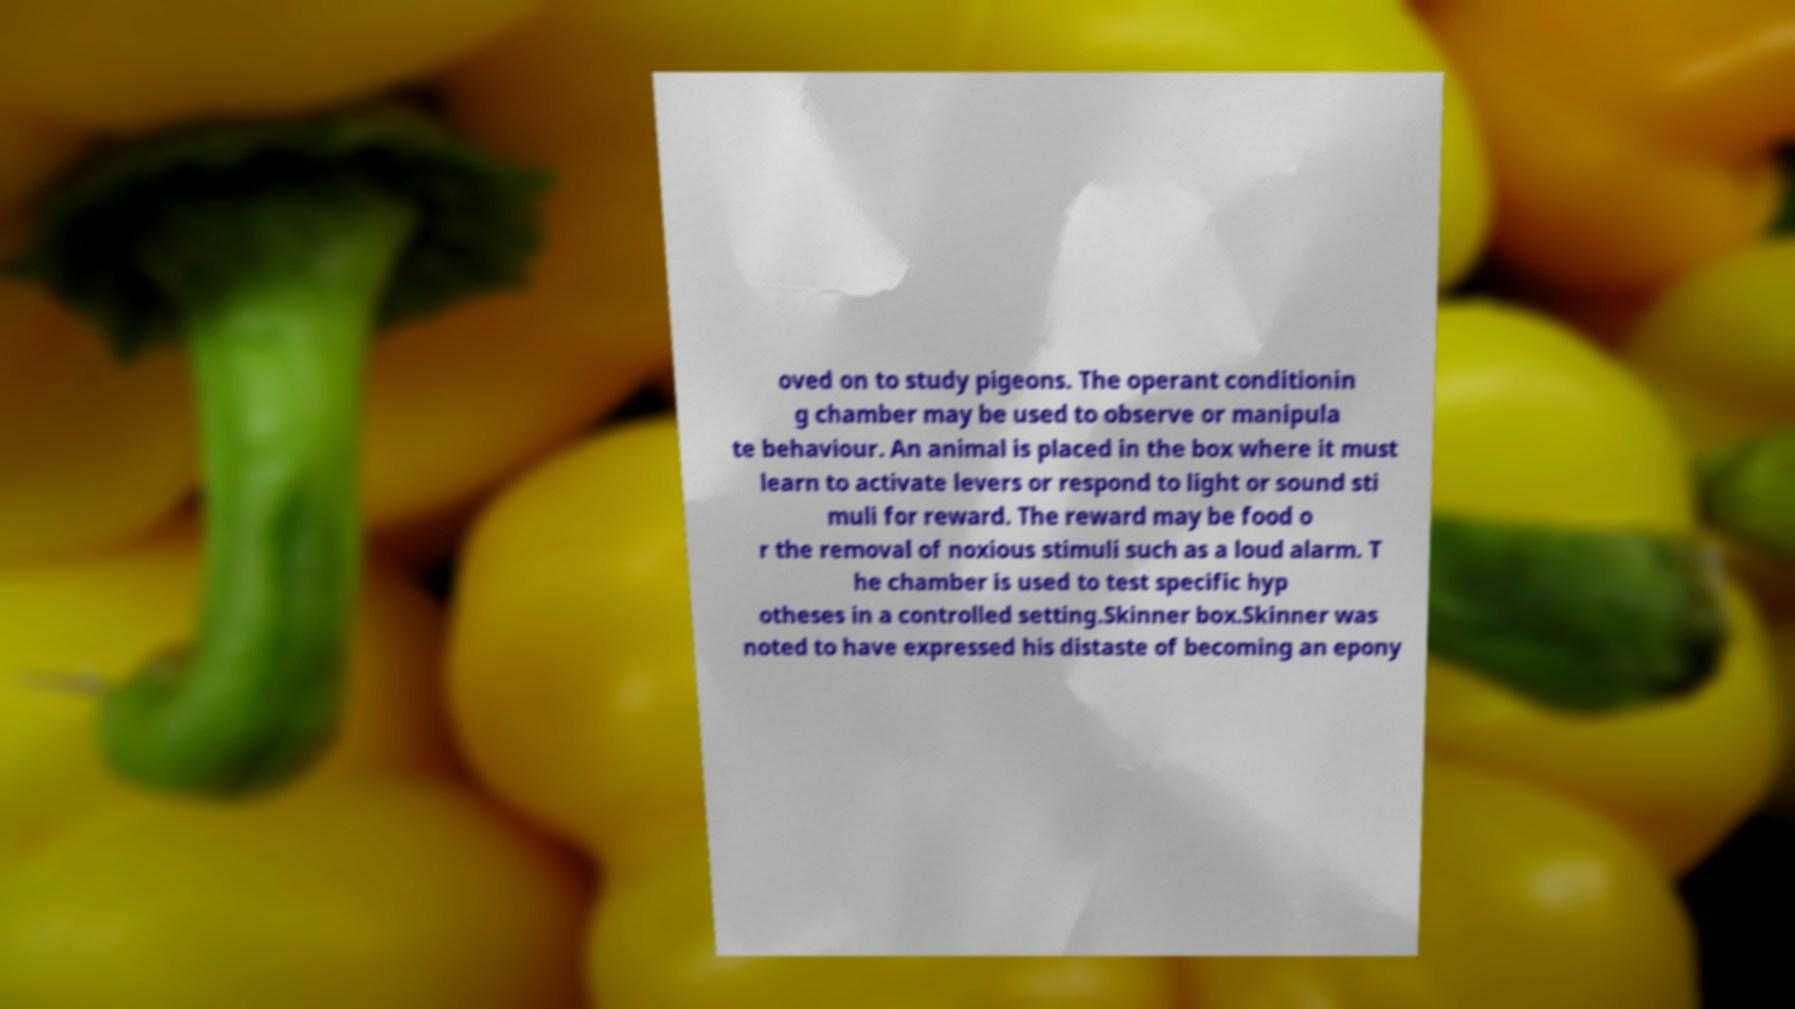Please read and relay the text visible in this image. What does it say? oved on to study pigeons. The operant conditionin g chamber may be used to observe or manipula te behaviour. An animal is placed in the box where it must learn to activate levers or respond to light or sound sti muli for reward. The reward may be food o r the removal of noxious stimuli such as a loud alarm. T he chamber is used to test specific hyp otheses in a controlled setting.Skinner box.Skinner was noted to have expressed his distaste of becoming an epony 